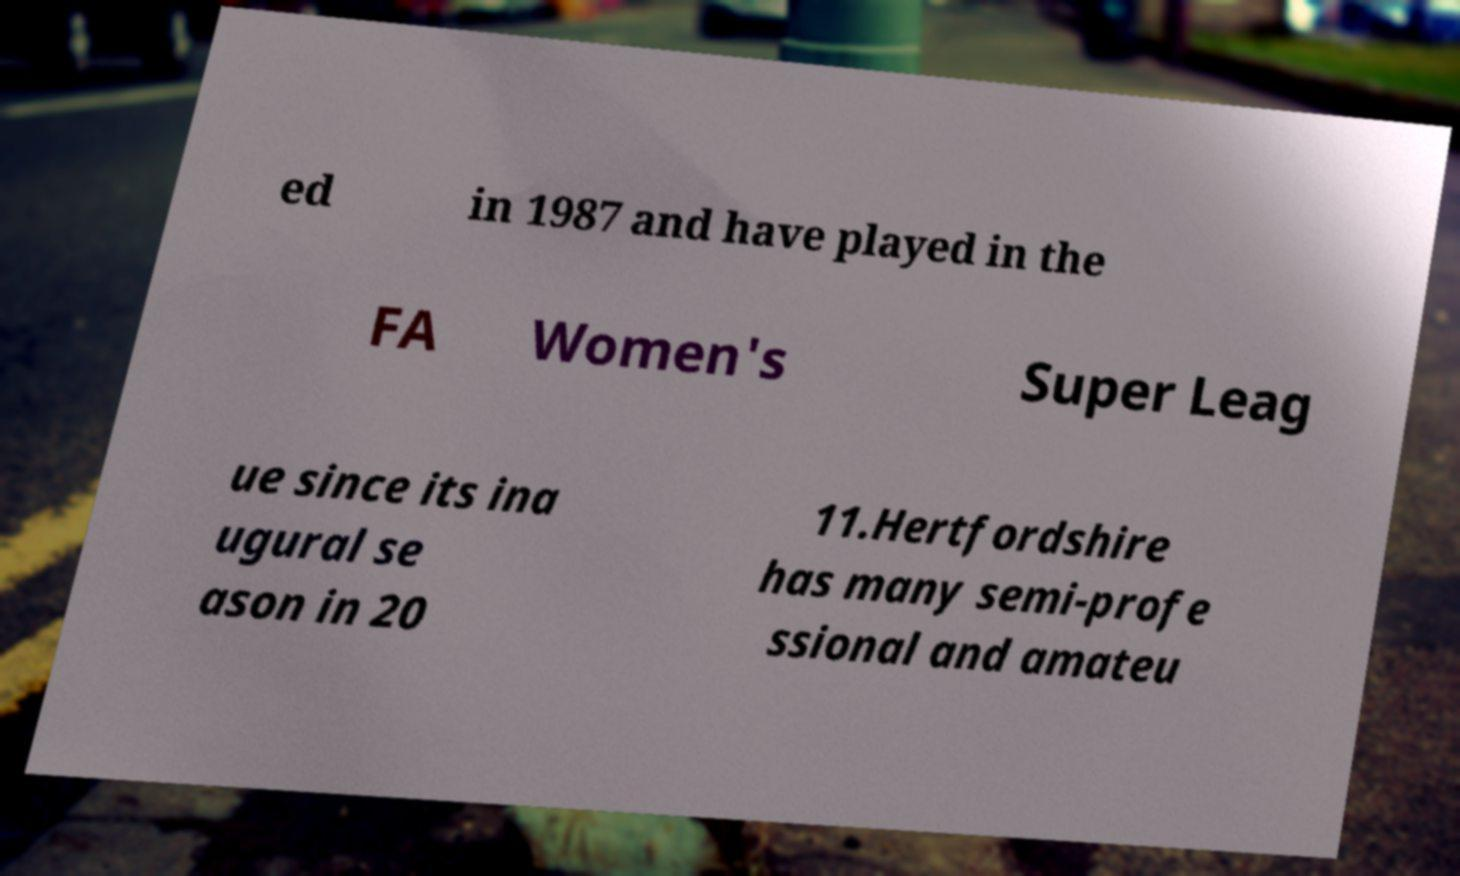Can you read and provide the text displayed in the image?This photo seems to have some interesting text. Can you extract and type it out for me? ed in 1987 and have played in the FA Women's Super Leag ue since its ina ugural se ason in 20 11.Hertfordshire has many semi-profe ssional and amateu 